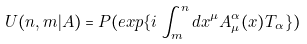Convert formula to latex. <formula><loc_0><loc_0><loc_500><loc_500>U ( n , m | A ) = P ( e x p \{ i \int _ { m } ^ { n } d x ^ { \mu } A _ { \mu } ^ { \alpha } ( x ) T _ { \alpha } \} )</formula> 